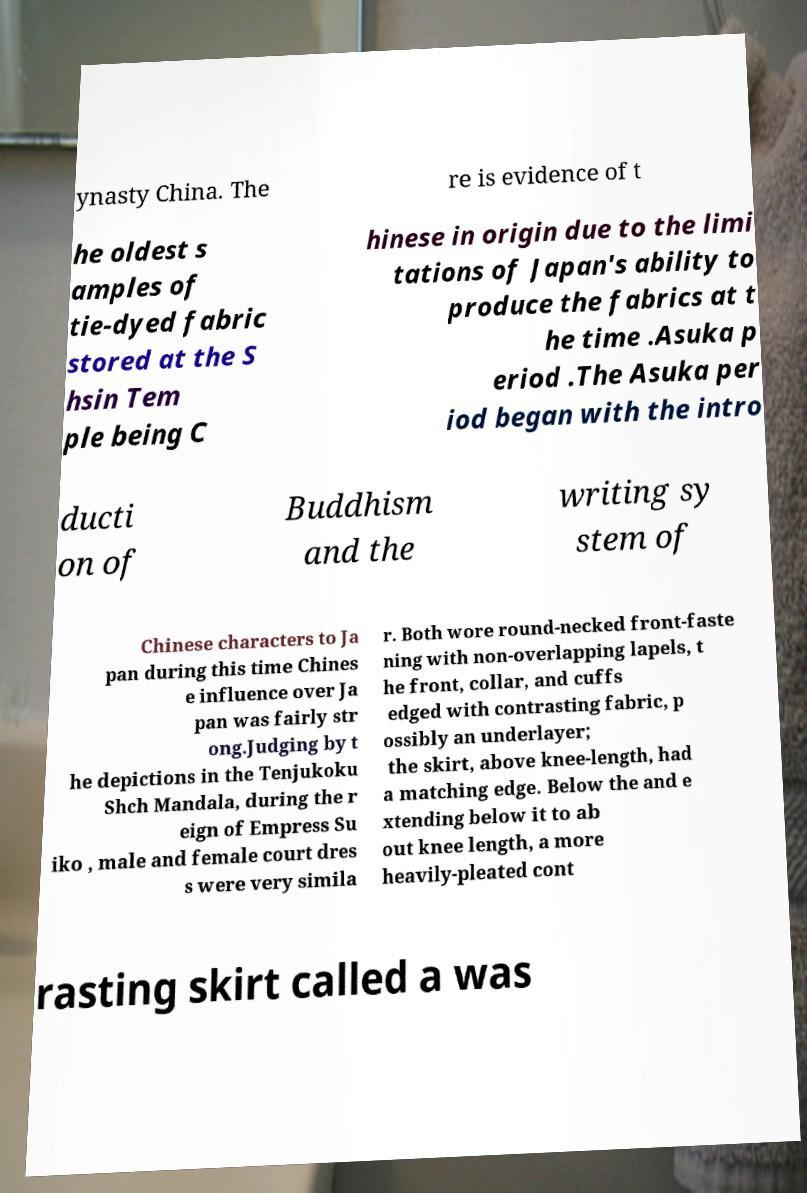Please identify and transcribe the text found in this image. ynasty China. The re is evidence of t he oldest s amples of tie-dyed fabric stored at the S hsin Tem ple being C hinese in origin due to the limi tations of Japan's ability to produce the fabrics at t he time .Asuka p eriod .The Asuka per iod began with the intro ducti on of Buddhism and the writing sy stem of Chinese characters to Ja pan during this time Chines e influence over Ja pan was fairly str ong.Judging by t he depictions in the Tenjukoku Shch Mandala, during the r eign of Empress Su iko , male and female court dres s were very simila r. Both wore round-necked front-faste ning with non-overlapping lapels, t he front, collar, and cuffs edged with contrasting fabric, p ossibly an underlayer; the skirt, above knee-length, had a matching edge. Below the and e xtending below it to ab out knee length, a more heavily-pleated cont rasting skirt called a was 